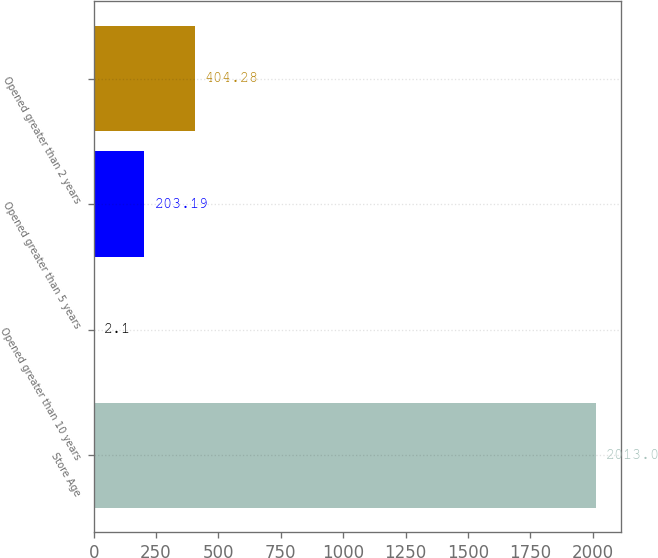Convert chart to OTSL. <chart><loc_0><loc_0><loc_500><loc_500><bar_chart><fcel>Store Age<fcel>Opened greater than 10 years<fcel>Opened greater than 5 years<fcel>Opened greater than 2 years<nl><fcel>2013<fcel>2.1<fcel>203.19<fcel>404.28<nl></chart> 